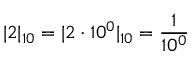<formula> <loc_0><loc_0><loc_500><loc_500>| 2 | _ { 1 0 } = | 2 \cdot 1 0 ^ { 0 } | _ { 1 0 } = { \frac { 1 } { 1 0 ^ { 0 } } }</formula> 